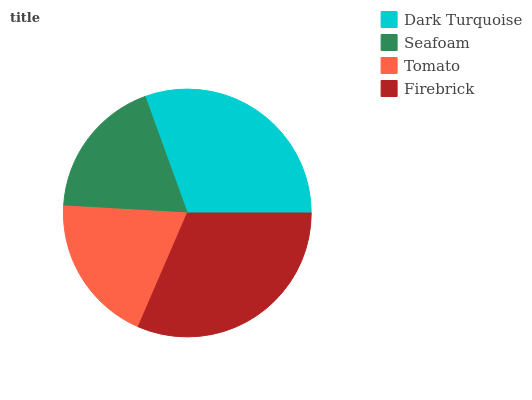Is Seafoam the minimum?
Answer yes or no. Yes. Is Firebrick the maximum?
Answer yes or no. Yes. Is Tomato the minimum?
Answer yes or no. No. Is Tomato the maximum?
Answer yes or no. No. Is Tomato greater than Seafoam?
Answer yes or no. Yes. Is Seafoam less than Tomato?
Answer yes or no. Yes. Is Seafoam greater than Tomato?
Answer yes or no. No. Is Tomato less than Seafoam?
Answer yes or no. No. Is Dark Turquoise the high median?
Answer yes or no. Yes. Is Tomato the low median?
Answer yes or no. Yes. Is Seafoam the high median?
Answer yes or no. No. Is Dark Turquoise the low median?
Answer yes or no. No. 